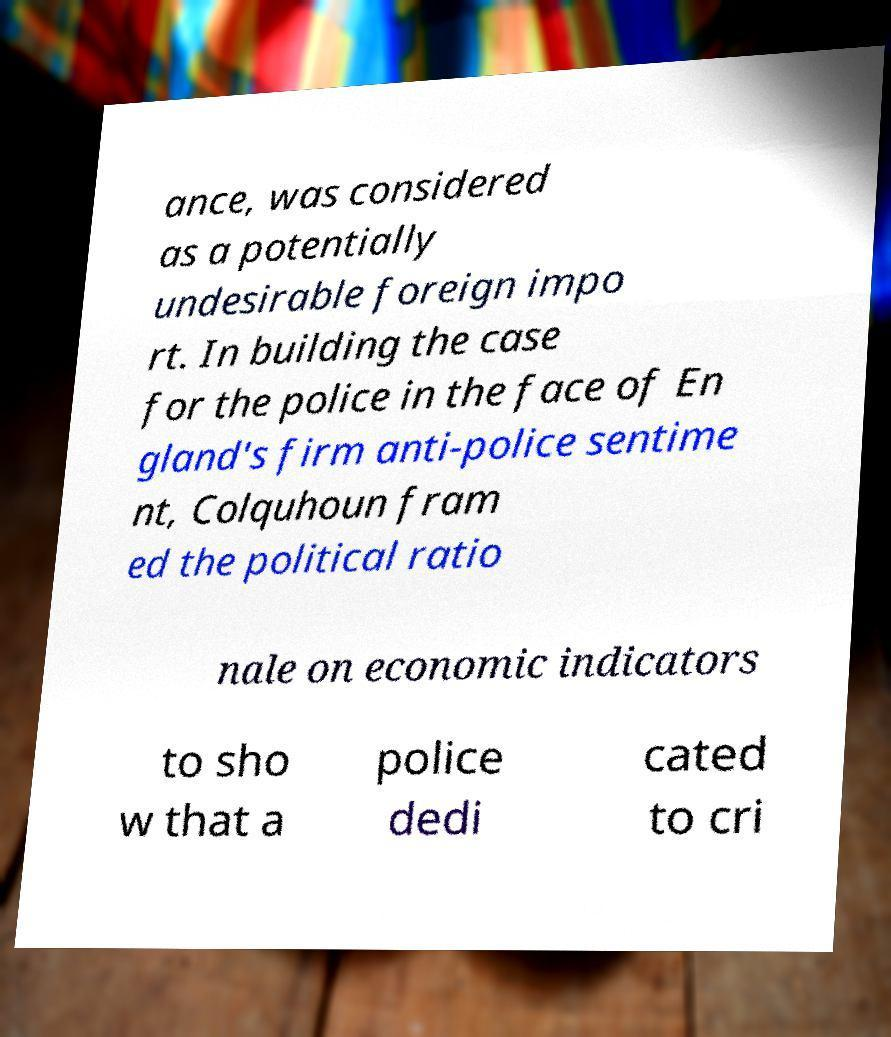I need the written content from this picture converted into text. Can you do that? ance, was considered as a potentially undesirable foreign impo rt. In building the case for the police in the face of En gland's firm anti-police sentime nt, Colquhoun fram ed the political ratio nale on economic indicators to sho w that a police dedi cated to cri 